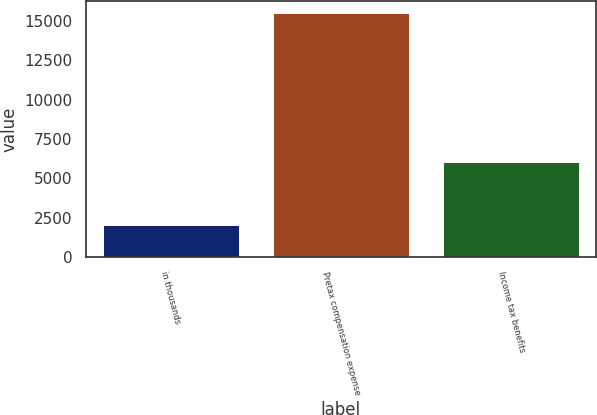Convert chart. <chart><loc_0><loc_0><loc_500><loc_500><bar_chart><fcel>in thousands<fcel>Pretax compensation expense<fcel>Income tax benefits<nl><fcel>2012<fcel>15491<fcel>6011<nl></chart> 